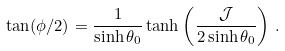<formula> <loc_0><loc_0><loc_500><loc_500>\tan ( \phi / 2 ) = \frac { 1 } { \sinh \theta _ { 0 } } \tanh \left ( \frac { \mathcal { J } } { 2 \sinh \theta _ { 0 } } \right ) \, .</formula> 